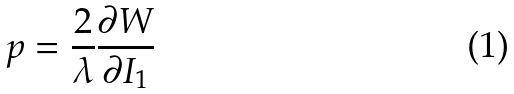Convert formula to latex. <formula><loc_0><loc_0><loc_500><loc_500>p = \frac { 2 } { \lambda } \frac { \partial W } { \partial I _ { 1 } }</formula> 